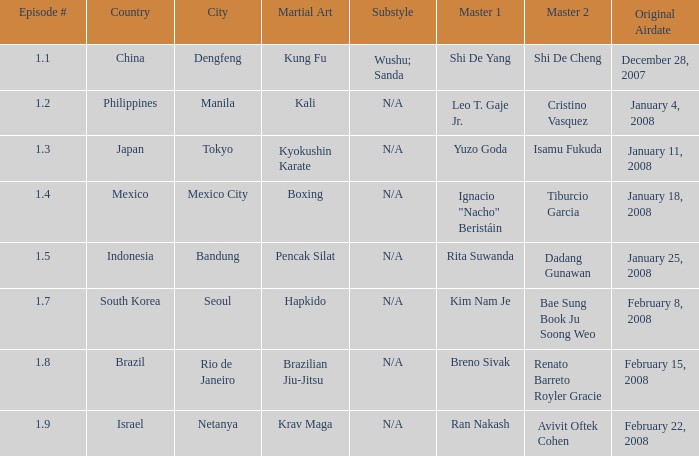How many times did episode 1.8 air? 1.0. 